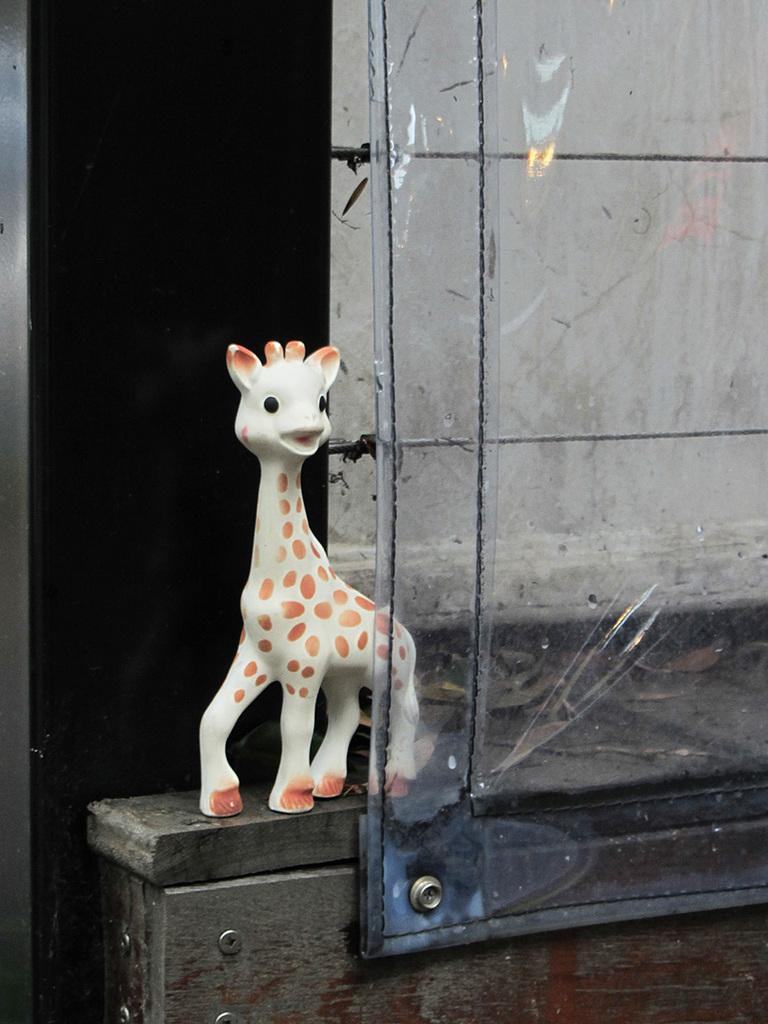Who or what is in the image? There is a person in the image. What is the person standing or sitting on? The person is on a wooden surface. What other object can be seen in the image? There is a toy in the image. What is the transparent sheet used for? The transparent sheet is not described in the facts, so we cannot determine its purpose. What can be seen in the background of the image? There is a black rod in the background of the image. How many bottles are visible in the image? There is no mention of any bottles in the image, so we cannot determine their presence or quantity. 